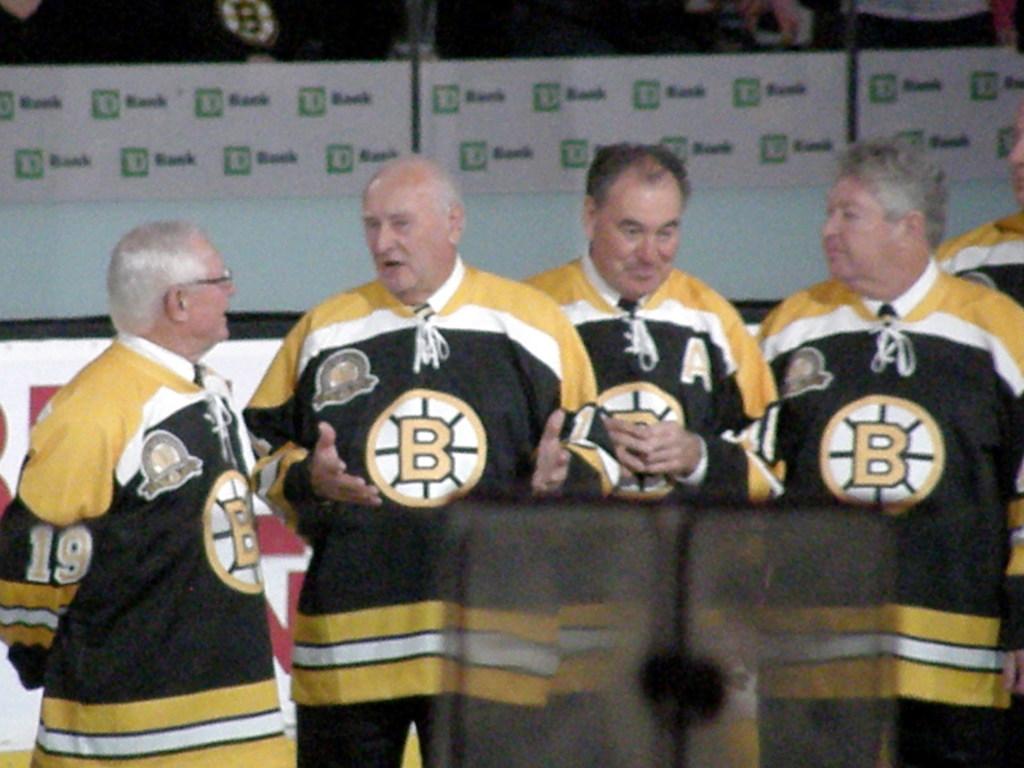What is the letter on the men's shirt?
Your response must be concise. B. What number is the man on the left?
Offer a terse response. 19. 